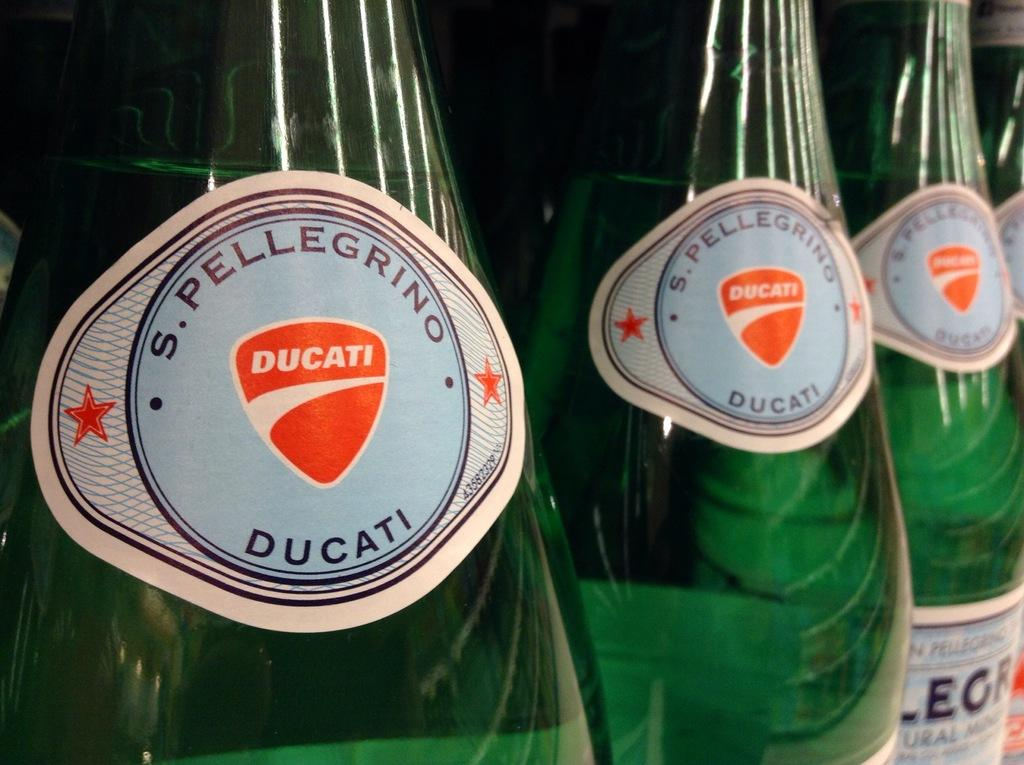<image>
Relay a brief, clear account of the picture shown. Three green bottles of S. Pelligrino Ducati lined up next to each other 